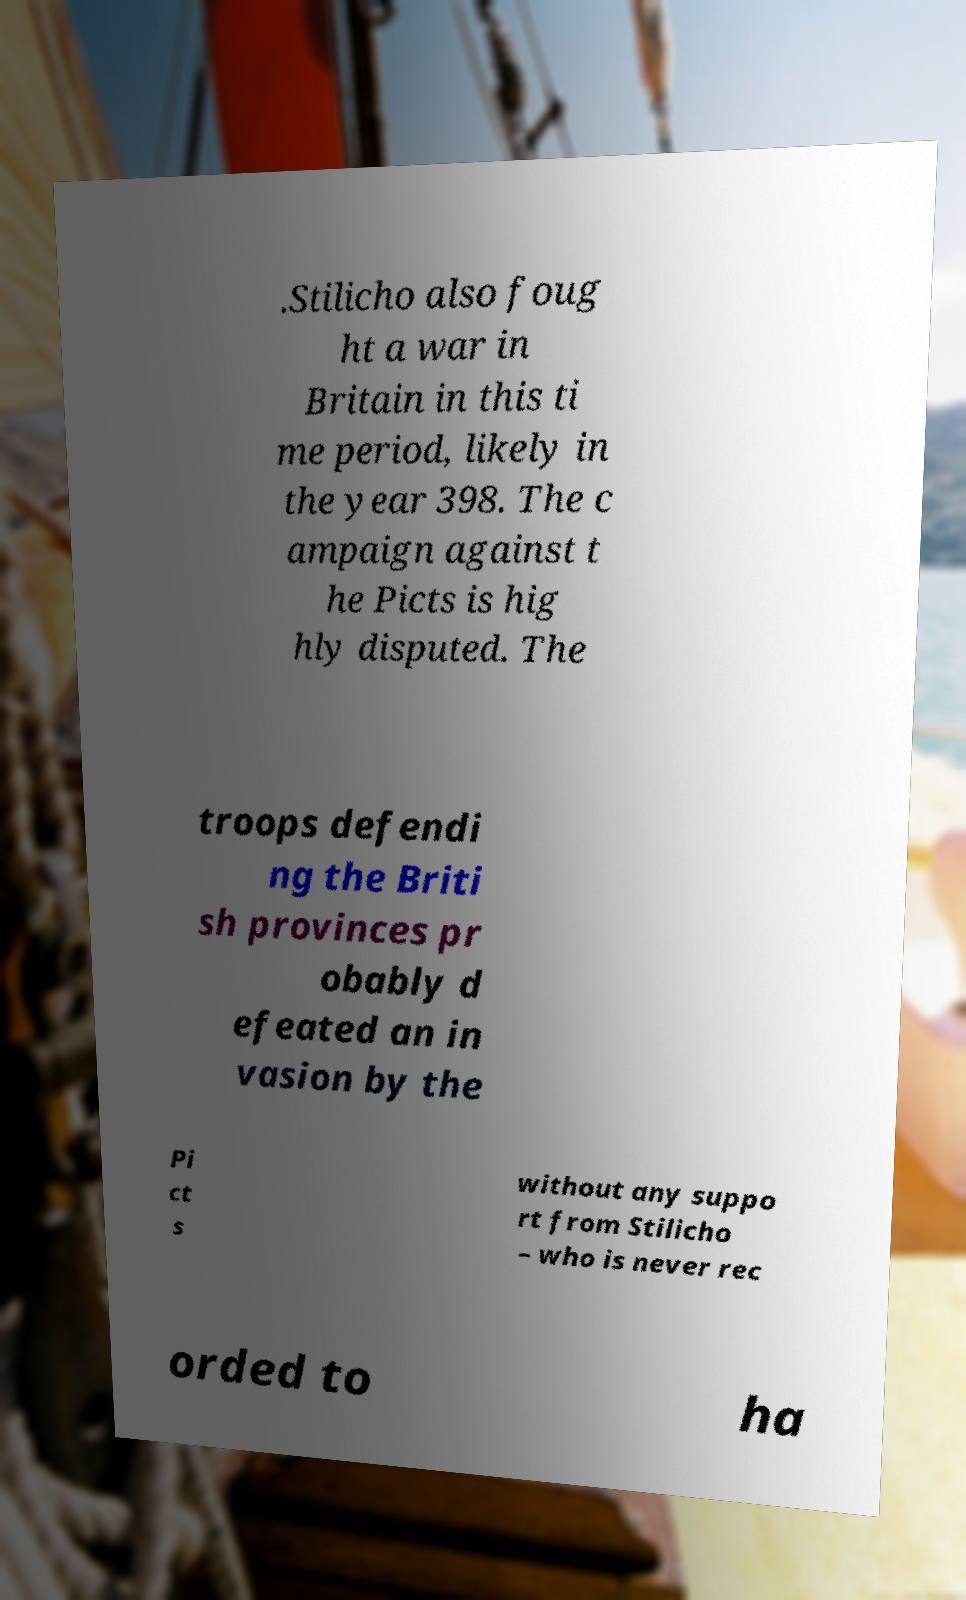Can you read and provide the text displayed in the image?This photo seems to have some interesting text. Can you extract and type it out for me? .Stilicho also foug ht a war in Britain in this ti me period, likely in the year 398. The c ampaign against t he Picts is hig hly disputed. The troops defendi ng the Briti sh provinces pr obably d efeated an in vasion by the Pi ct s without any suppo rt from Stilicho – who is never rec orded to ha 